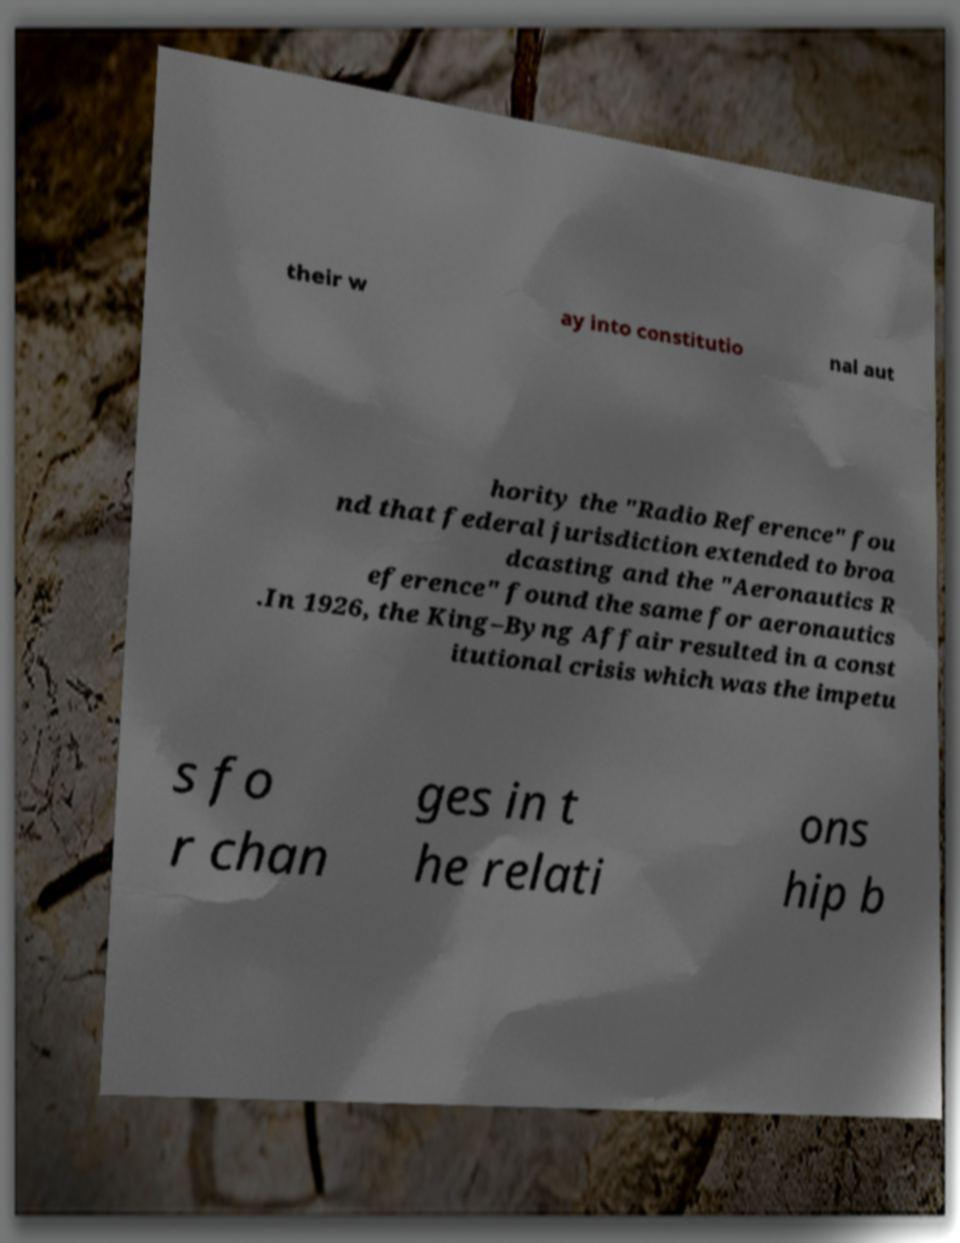There's text embedded in this image that I need extracted. Can you transcribe it verbatim? their w ay into constitutio nal aut hority the "Radio Reference" fou nd that federal jurisdiction extended to broa dcasting and the "Aeronautics R eference" found the same for aeronautics .In 1926, the King–Byng Affair resulted in a const itutional crisis which was the impetu s fo r chan ges in t he relati ons hip b 